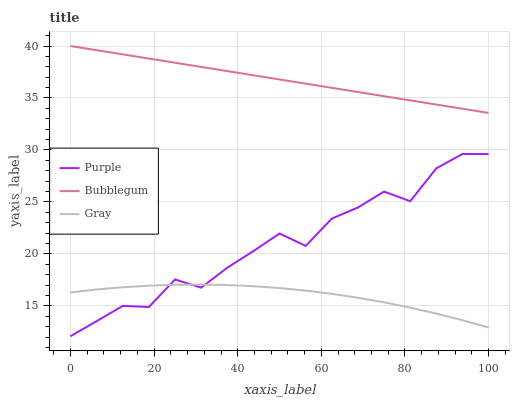Does Bubblegum have the minimum area under the curve?
Answer yes or no. No. Does Gray have the maximum area under the curve?
Answer yes or no. No. Is Gray the smoothest?
Answer yes or no. No. Is Gray the roughest?
Answer yes or no. No. Does Gray have the lowest value?
Answer yes or no. No. Does Gray have the highest value?
Answer yes or no. No. Is Gray less than Bubblegum?
Answer yes or no. Yes. Is Bubblegum greater than Gray?
Answer yes or no. Yes. Does Gray intersect Bubblegum?
Answer yes or no. No. 